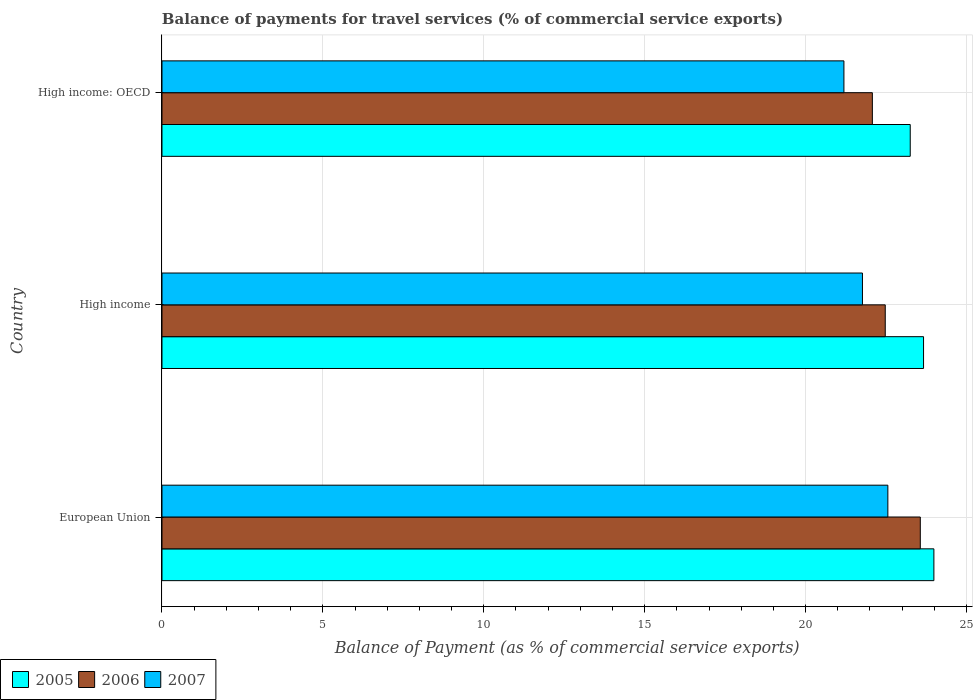How many groups of bars are there?
Your response must be concise. 3. Are the number of bars per tick equal to the number of legend labels?
Ensure brevity in your answer.  Yes. What is the label of the 1st group of bars from the top?
Ensure brevity in your answer.  High income: OECD. What is the balance of payments for travel services in 2006 in High income?
Give a very brief answer. 22.47. Across all countries, what is the maximum balance of payments for travel services in 2006?
Your answer should be very brief. 23.56. Across all countries, what is the minimum balance of payments for travel services in 2007?
Give a very brief answer. 21.19. In which country was the balance of payments for travel services in 2006 minimum?
Provide a short and direct response. High income: OECD. What is the total balance of payments for travel services in 2005 in the graph?
Offer a terse response. 70.9. What is the difference between the balance of payments for travel services in 2007 in High income and that in High income: OECD?
Provide a short and direct response. 0.58. What is the difference between the balance of payments for travel services in 2007 in High income: OECD and the balance of payments for travel services in 2005 in European Union?
Make the answer very short. -2.8. What is the average balance of payments for travel services in 2005 per country?
Provide a succinct answer. 23.63. What is the difference between the balance of payments for travel services in 2005 and balance of payments for travel services in 2006 in European Union?
Your response must be concise. 0.42. In how many countries, is the balance of payments for travel services in 2005 greater than 24 %?
Your answer should be compact. 0. What is the ratio of the balance of payments for travel services in 2005 in High income to that in High income: OECD?
Your response must be concise. 1.02. Is the balance of payments for travel services in 2005 in High income less than that in High income: OECD?
Ensure brevity in your answer.  No. What is the difference between the highest and the second highest balance of payments for travel services in 2005?
Keep it short and to the point. 0.32. What is the difference between the highest and the lowest balance of payments for travel services in 2006?
Your answer should be very brief. 1.49. Is the sum of the balance of payments for travel services in 2005 in European Union and High income: OECD greater than the maximum balance of payments for travel services in 2006 across all countries?
Your response must be concise. Yes. How many bars are there?
Offer a very short reply. 9. How many countries are there in the graph?
Your answer should be compact. 3. Are the values on the major ticks of X-axis written in scientific E-notation?
Keep it short and to the point. No. Does the graph contain any zero values?
Provide a short and direct response. No. Where does the legend appear in the graph?
Keep it short and to the point. Bottom left. How many legend labels are there?
Provide a succinct answer. 3. How are the legend labels stacked?
Keep it short and to the point. Horizontal. What is the title of the graph?
Ensure brevity in your answer.  Balance of payments for travel services (% of commercial service exports). Does "1981" appear as one of the legend labels in the graph?
Provide a succinct answer. No. What is the label or title of the X-axis?
Provide a short and direct response. Balance of Payment (as % of commercial service exports). What is the label or title of the Y-axis?
Provide a succinct answer. Country. What is the Balance of Payment (as % of commercial service exports) in 2005 in European Union?
Your answer should be compact. 23.99. What is the Balance of Payment (as % of commercial service exports) of 2006 in European Union?
Provide a short and direct response. 23.56. What is the Balance of Payment (as % of commercial service exports) of 2007 in European Union?
Keep it short and to the point. 22.56. What is the Balance of Payment (as % of commercial service exports) of 2005 in High income?
Provide a succinct answer. 23.66. What is the Balance of Payment (as % of commercial service exports) of 2006 in High income?
Your response must be concise. 22.47. What is the Balance of Payment (as % of commercial service exports) of 2007 in High income?
Make the answer very short. 21.77. What is the Balance of Payment (as % of commercial service exports) in 2005 in High income: OECD?
Your answer should be compact. 23.25. What is the Balance of Payment (as % of commercial service exports) of 2006 in High income: OECD?
Offer a terse response. 22.07. What is the Balance of Payment (as % of commercial service exports) of 2007 in High income: OECD?
Make the answer very short. 21.19. Across all countries, what is the maximum Balance of Payment (as % of commercial service exports) of 2005?
Make the answer very short. 23.99. Across all countries, what is the maximum Balance of Payment (as % of commercial service exports) of 2006?
Provide a succinct answer. 23.56. Across all countries, what is the maximum Balance of Payment (as % of commercial service exports) of 2007?
Make the answer very short. 22.56. Across all countries, what is the minimum Balance of Payment (as % of commercial service exports) in 2005?
Offer a terse response. 23.25. Across all countries, what is the minimum Balance of Payment (as % of commercial service exports) of 2006?
Your response must be concise. 22.07. Across all countries, what is the minimum Balance of Payment (as % of commercial service exports) of 2007?
Offer a terse response. 21.19. What is the total Balance of Payment (as % of commercial service exports) in 2005 in the graph?
Offer a terse response. 70.9. What is the total Balance of Payment (as % of commercial service exports) in 2006 in the graph?
Offer a terse response. 68.11. What is the total Balance of Payment (as % of commercial service exports) of 2007 in the graph?
Your answer should be very brief. 65.51. What is the difference between the Balance of Payment (as % of commercial service exports) of 2005 in European Union and that in High income?
Your response must be concise. 0.32. What is the difference between the Balance of Payment (as % of commercial service exports) of 2006 in European Union and that in High income?
Keep it short and to the point. 1.09. What is the difference between the Balance of Payment (as % of commercial service exports) of 2007 in European Union and that in High income?
Give a very brief answer. 0.79. What is the difference between the Balance of Payment (as % of commercial service exports) in 2005 in European Union and that in High income: OECD?
Make the answer very short. 0.74. What is the difference between the Balance of Payment (as % of commercial service exports) in 2006 in European Union and that in High income: OECD?
Provide a succinct answer. 1.49. What is the difference between the Balance of Payment (as % of commercial service exports) of 2007 in European Union and that in High income: OECD?
Your response must be concise. 1.37. What is the difference between the Balance of Payment (as % of commercial service exports) of 2005 in High income and that in High income: OECD?
Ensure brevity in your answer.  0.41. What is the difference between the Balance of Payment (as % of commercial service exports) in 2006 in High income and that in High income: OECD?
Keep it short and to the point. 0.4. What is the difference between the Balance of Payment (as % of commercial service exports) of 2007 in High income and that in High income: OECD?
Offer a terse response. 0.58. What is the difference between the Balance of Payment (as % of commercial service exports) of 2005 in European Union and the Balance of Payment (as % of commercial service exports) of 2006 in High income?
Your response must be concise. 1.51. What is the difference between the Balance of Payment (as % of commercial service exports) of 2005 in European Union and the Balance of Payment (as % of commercial service exports) of 2007 in High income?
Your response must be concise. 2.22. What is the difference between the Balance of Payment (as % of commercial service exports) of 2006 in European Union and the Balance of Payment (as % of commercial service exports) of 2007 in High income?
Your response must be concise. 1.8. What is the difference between the Balance of Payment (as % of commercial service exports) of 2005 in European Union and the Balance of Payment (as % of commercial service exports) of 2006 in High income: OECD?
Your answer should be very brief. 1.91. What is the difference between the Balance of Payment (as % of commercial service exports) of 2005 in European Union and the Balance of Payment (as % of commercial service exports) of 2007 in High income: OECD?
Provide a short and direct response. 2.8. What is the difference between the Balance of Payment (as % of commercial service exports) in 2006 in European Union and the Balance of Payment (as % of commercial service exports) in 2007 in High income: OECD?
Make the answer very short. 2.37. What is the difference between the Balance of Payment (as % of commercial service exports) in 2005 in High income and the Balance of Payment (as % of commercial service exports) in 2006 in High income: OECD?
Your response must be concise. 1.59. What is the difference between the Balance of Payment (as % of commercial service exports) of 2005 in High income and the Balance of Payment (as % of commercial service exports) of 2007 in High income: OECD?
Your answer should be compact. 2.47. What is the difference between the Balance of Payment (as % of commercial service exports) in 2006 in High income and the Balance of Payment (as % of commercial service exports) in 2007 in High income: OECD?
Your answer should be compact. 1.28. What is the average Balance of Payment (as % of commercial service exports) of 2005 per country?
Your answer should be very brief. 23.63. What is the average Balance of Payment (as % of commercial service exports) in 2006 per country?
Your answer should be compact. 22.7. What is the average Balance of Payment (as % of commercial service exports) in 2007 per country?
Ensure brevity in your answer.  21.84. What is the difference between the Balance of Payment (as % of commercial service exports) in 2005 and Balance of Payment (as % of commercial service exports) in 2006 in European Union?
Ensure brevity in your answer.  0.42. What is the difference between the Balance of Payment (as % of commercial service exports) in 2005 and Balance of Payment (as % of commercial service exports) in 2007 in European Union?
Offer a terse response. 1.43. What is the difference between the Balance of Payment (as % of commercial service exports) of 2006 and Balance of Payment (as % of commercial service exports) of 2007 in European Union?
Give a very brief answer. 1.01. What is the difference between the Balance of Payment (as % of commercial service exports) in 2005 and Balance of Payment (as % of commercial service exports) in 2006 in High income?
Provide a succinct answer. 1.19. What is the difference between the Balance of Payment (as % of commercial service exports) of 2005 and Balance of Payment (as % of commercial service exports) of 2007 in High income?
Offer a very short reply. 1.9. What is the difference between the Balance of Payment (as % of commercial service exports) in 2006 and Balance of Payment (as % of commercial service exports) in 2007 in High income?
Give a very brief answer. 0.71. What is the difference between the Balance of Payment (as % of commercial service exports) of 2005 and Balance of Payment (as % of commercial service exports) of 2006 in High income: OECD?
Offer a terse response. 1.18. What is the difference between the Balance of Payment (as % of commercial service exports) in 2005 and Balance of Payment (as % of commercial service exports) in 2007 in High income: OECD?
Provide a succinct answer. 2.06. What is the difference between the Balance of Payment (as % of commercial service exports) in 2006 and Balance of Payment (as % of commercial service exports) in 2007 in High income: OECD?
Offer a very short reply. 0.88. What is the ratio of the Balance of Payment (as % of commercial service exports) in 2005 in European Union to that in High income?
Make the answer very short. 1.01. What is the ratio of the Balance of Payment (as % of commercial service exports) of 2006 in European Union to that in High income?
Give a very brief answer. 1.05. What is the ratio of the Balance of Payment (as % of commercial service exports) in 2007 in European Union to that in High income?
Provide a succinct answer. 1.04. What is the ratio of the Balance of Payment (as % of commercial service exports) of 2005 in European Union to that in High income: OECD?
Provide a short and direct response. 1.03. What is the ratio of the Balance of Payment (as % of commercial service exports) of 2006 in European Union to that in High income: OECD?
Provide a succinct answer. 1.07. What is the ratio of the Balance of Payment (as % of commercial service exports) in 2007 in European Union to that in High income: OECD?
Your response must be concise. 1.06. What is the ratio of the Balance of Payment (as % of commercial service exports) in 2005 in High income to that in High income: OECD?
Ensure brevity in your answer.  1.02. What is the ratio of the Balance of Payment (as % of commercial service exports) of 2006 in High income to that in High income: OECD?
Make the answer very short. 1.02. What is the ratio of the Balance of Payment (as % of commercial service exports) in 2007 in High income to that in High income: OECD?
Provide a succinct answer. 1.03. What is the difference between the highest and the second highest Balance of Payment (as % of commercial service exports) in 2005?
Make the answer very short. 0.32. What is the difference between the highest and the second highest Balance of Payment (as % of commercial service exports) in 2006?
Offer a very short reply. 1.09. What is the difference between the highest and the second highest Balance of Payment (as % of commercial service exports) of 2007?
Your answer should be very brief. 0.79. What is the difference between the highest and the lowest Balance of Payment (as % of commercial service exports) of 2005?
Offer a terse response. 0.74. What is the difference between the highest and the lowest Balance of Payment (as % of commercial service exports) of 2006?
Provide a succinct answer. 1.49. What is the difference between the highest and the lowest Balance of Payment (as % of commercial service exports) in 2007?
Provide a succinct answer. 1.37. 